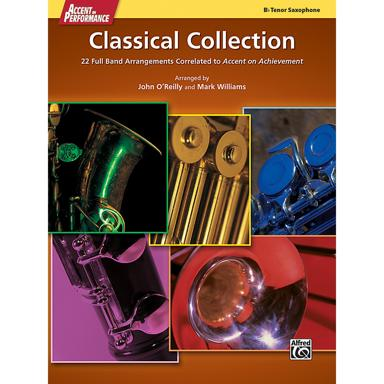What is the name of the classical collection mentioned in the image? The classical collection featured in the image is entitled 'Tenor Saxophone Classical Collection,' which is specifically designed for tenor saxophonists seeking classical material for performance and study. 